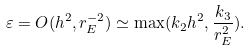<formula> <loc_0><loc_0><loc_500><loc_500>\varepsilon = O ( h ^ { 2 } , r _ { E } ^ { - 2 } ) \simeq \max ( k _ { 2 } h ^ { 2 } , \frac { k _ { 3 } } { r _ { E } ^ { 2 } } ) .</formula> 